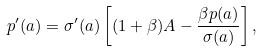<formula> <loc_0><loc_0><loc_500><loc_500>p ^ { \prime } ( a ) = { \sigma ^ { \prime } ( a ) } \left [ ( 1 + \beta ) A - \frac { \beta { p ( a ) } } { \sigma ( a ) } \right ] ,</formula> 